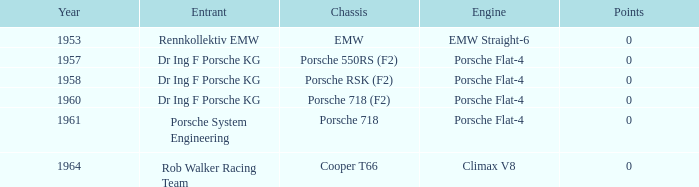What kind of engine powered the porsche 718's structure? Porsche Flat-4. 